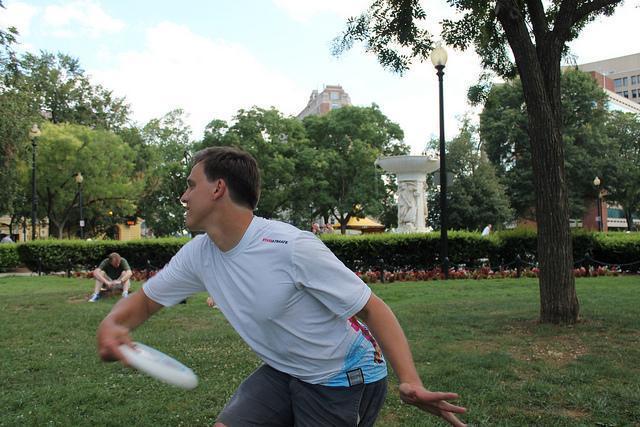How many people are in the photo?
Give a very brief answer. 2. 